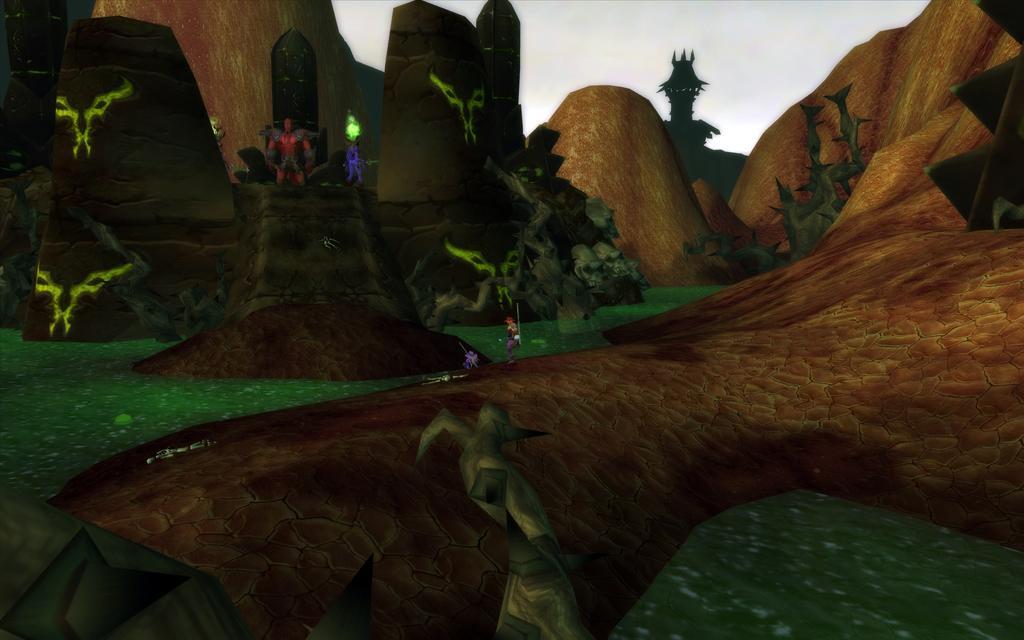Could you give a brief overview of what you see in this image? This is an animated image. In this image we can see hills and animated characters. 